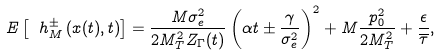Convert formula to latex. <formula><loc_0><loc_0><loc_500><loc_500>E \left [ \ h ^ { \pm } _ { M } \left ( x ( t ) , t \right ) \right ] = \frac { M \sigma ^ { 2 } _ { e } } { 2 M ^ { 2 } _ { T } Z _ { \Gamma } ( t ) } \left ( \alpha t \pm \frac { \gamma } { \sigma ^ { 2 } _ { e } } \right ) ^ { 2 } + M \frac { p ^ { 2 } _ { 0 } } { 2 M ^ { 2 } _ { T } } + \frac { \epsilon } { \overline { \tau } } ,</formula> 